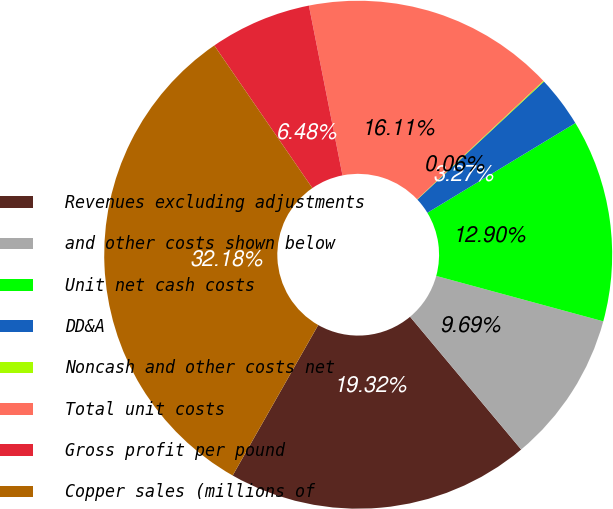Convert chart to OTSL. <chart><loc_0><loc_0><loc_500><loc_500><pie_chart><fcel>Revenues excluding adjustments<fcel>and other costs shown below<fcel>Unit net cash costs<fcel>DD&A<fcel>Noncash and other costs net<fcel>Total unit costs<fcel>Gross profit per pound<fcel>Copper sales (millions of<nl><fcel>19.32%<fcel>9.69%<fcel>12.9%<fcel>3.27%<fcel>0.06%<fcel>16.11%<fcel>6.48%<fcel>32.19%<nl></chart> 